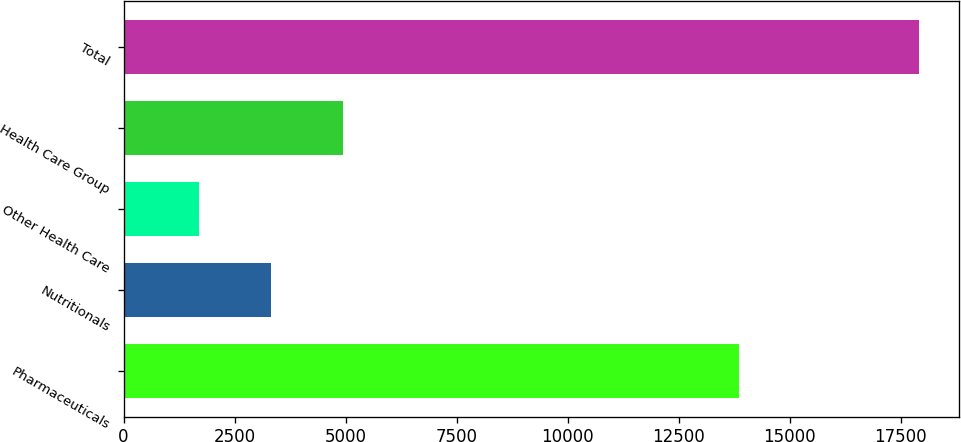Convert chart. <chart><loc_0><loc_0><loc_500><loc_500><bar_chart><fcel>Pharmaceuticals<fcel>Nutritionals<fcel>Other Health Care<fcel>Health Care Group<fcel>Total<nl><fcel>13861<fcel>3326.8<fcel>1706<fcel>4947.6<fcel>17914<nl></chart> 